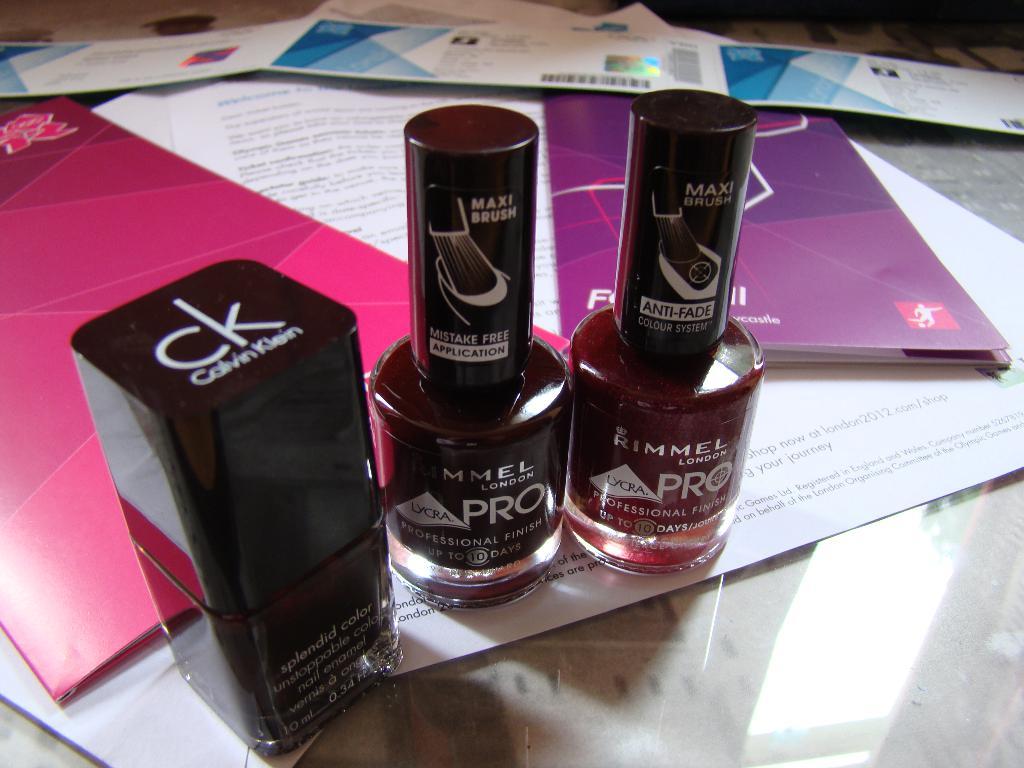What is the makeup brand on the far left bottle?
Make the answer very short. Calvin klein. What is the brand on the middle bottle?
Provide a succinct answer. Rimmel. 